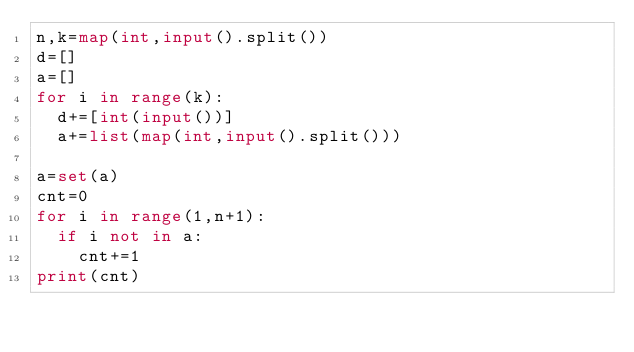<code> <loc_0><loc_0><loc_500><loc_500><_Python_>n,k=map(int,input().split())
d=[]
a=[]
for i in range(k):
  d+=[int(input())]
  a+=list(map(int,input().split()))

a=set(a)
cnt=0
for i in range(1,n+1):
  if i not in a:
    cnt+=1
print(cnt)</code> 